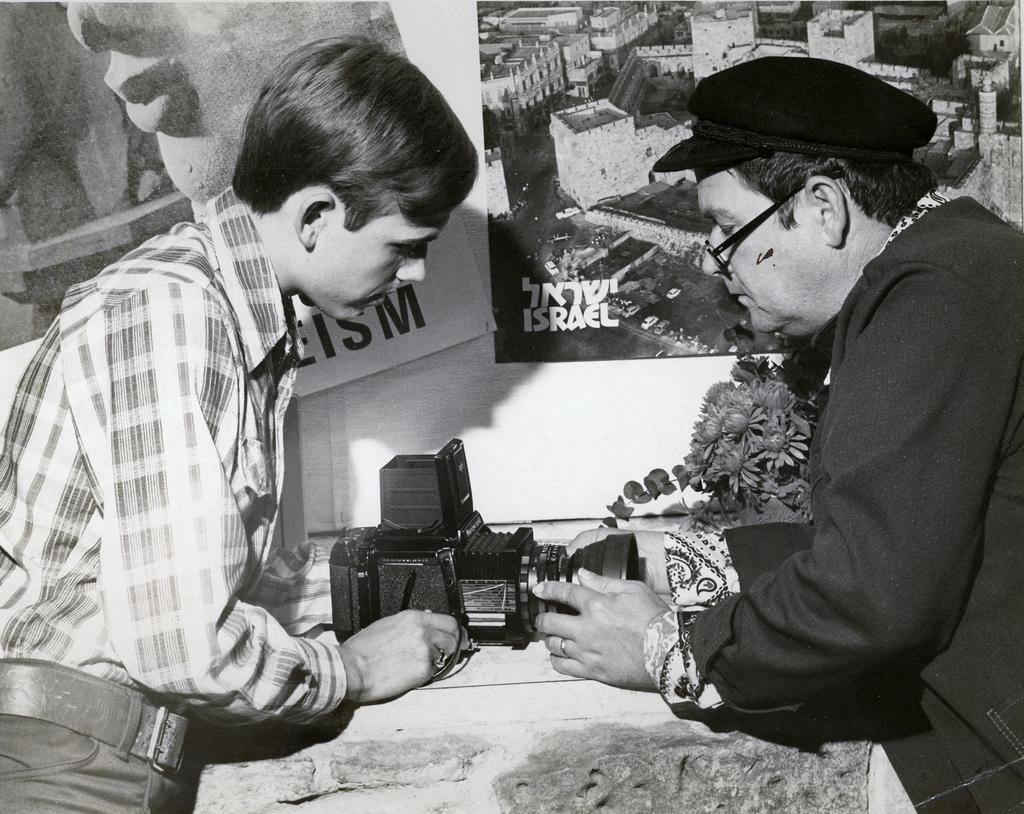How would you summarize this image in a sentence or two? In the image we can see there are two persons standing opposite to each other. This is a video camera. We can even see a poster on the wall. 